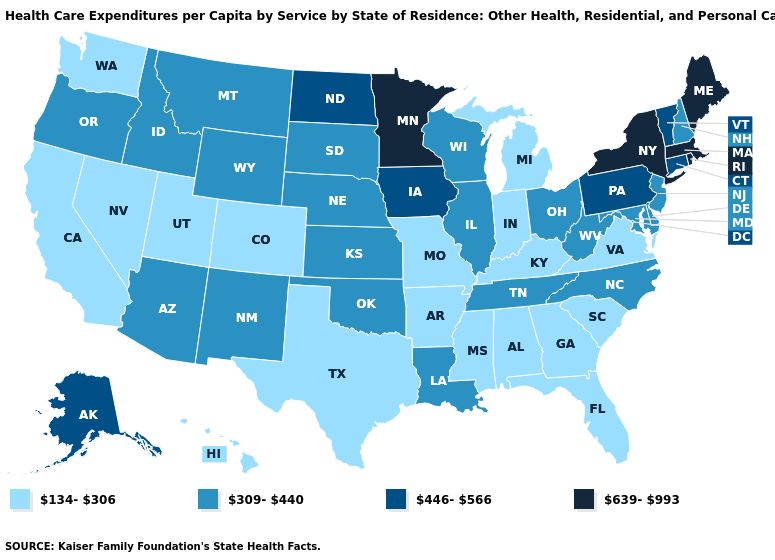How many symbols are there in the legend?
Short answer required. 4. What is the value of Alabama?
Keep it brief. 134-306. What is the value of Indiana?
Concise answer only. 134-306. Name the states that have a value in the range 309-440?
Keep it brief. Arizona, Delaware, Idaho, Illinois, Kansas, Louisiana, Maryland, Montana, Nebraska, New Hampshire, New Jersey, New Mexico, North Carolina, Ohio, Oklahoma, Oregon, South Dakota, Tennessee, West Virginia, Wisconsin, Wyoming. Name the states that have a value in the range 639-993?
Keep it brief. Maine, Massachusetts, Minnesota, New York, Rhode Island. Which states have the lowest value in the MidWest?
Short answer required. Indiana, Michigan, Missouri. Does Hawaii have a lower value than Utah?
Answer briefly. No. How many symbols are there in the legend?
Quick response, please. 4. Does Delaware have the highest value in the South?
Give a very brief answer. Yes. What is the value of Pennsylvania?
Short answer required. 446-566. Which states have the lowest value in the USA?
Answer briefly. Alabama, Arkansas, California, Colorado, Florida, Georgia, Hawaii, Indiana, Kentucky, Michigan, Mississippi, Missouri, Nevada, South Carolina, Texas, Utah, Virginia, Washington. How many symbols are there in the legend?
Be succinct. 4. What is the value of Virginia?
Answer briefly. 134-306. What is the value of Delaware?
Short answer required. 309-440. 